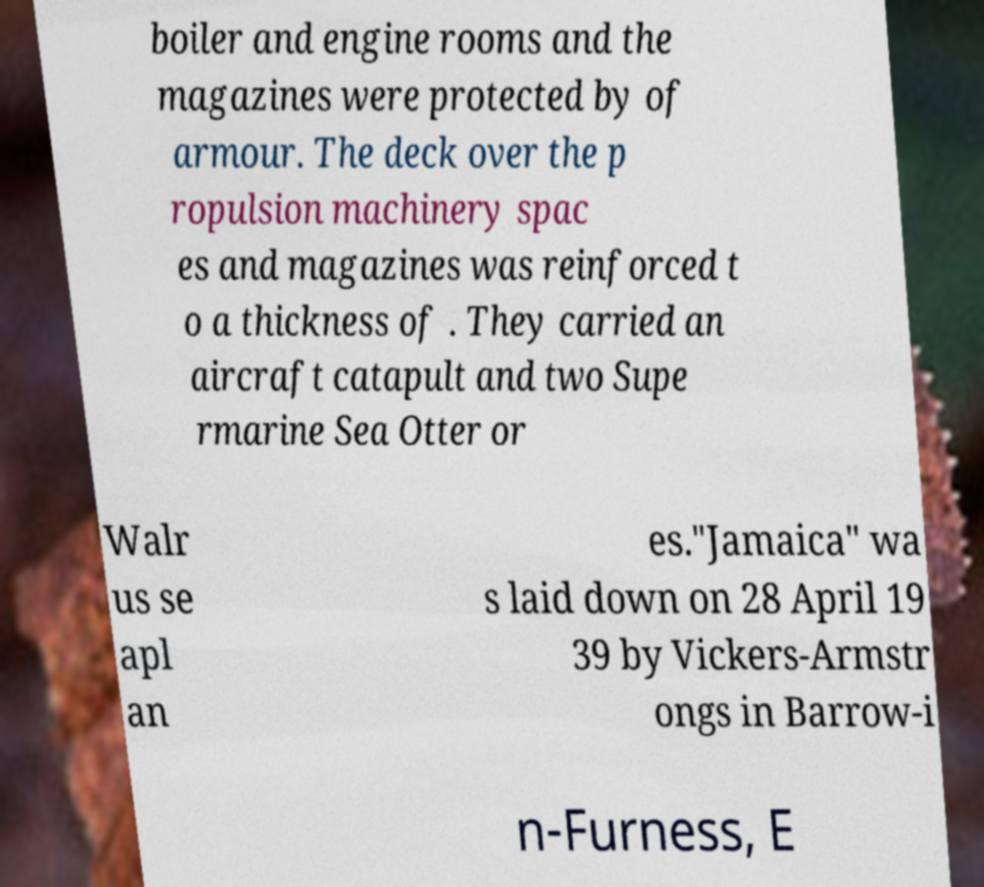Please read and relay the text visible in this image. What does it say? boiler and engine rooms and the magazines were protected by of armour. The deck over the p ropulsion machinery spac es and magazines was reinforced t o a thickness of . They carried an aircraft catapult and two Supe rmarine Sea Otter or Walr us se apl an es."Jamaica" wa s laid down on 28 April 19 39 by Vickers-Armstr ongs in Barrow-i n-Furness, E 